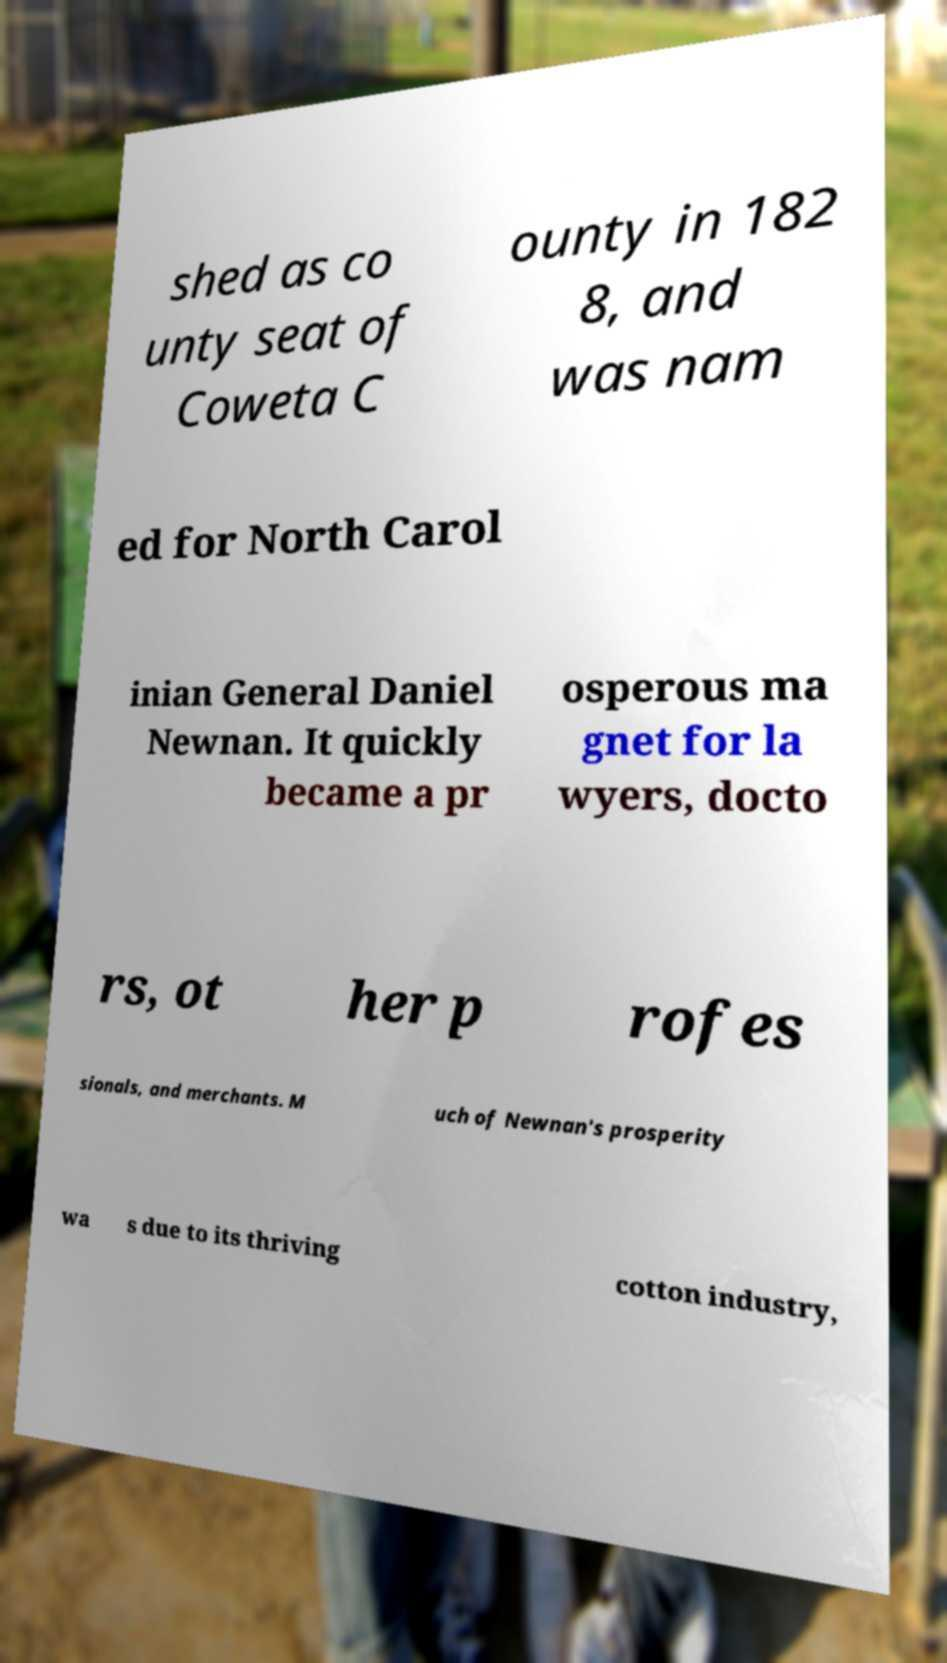Please read and relay the text visible in this image. What does it say? shed as co unty seat of Coweta C ounty in 182 8, and was nam ed for North Carol inian General Daniel Newnan. It quickly became a pr osperous ma gnet for la wyers, docto rs, ot her p rofes sionals, and merchants. M uch of Newnan's prosperity wa s due to its thriving cotton industry, 